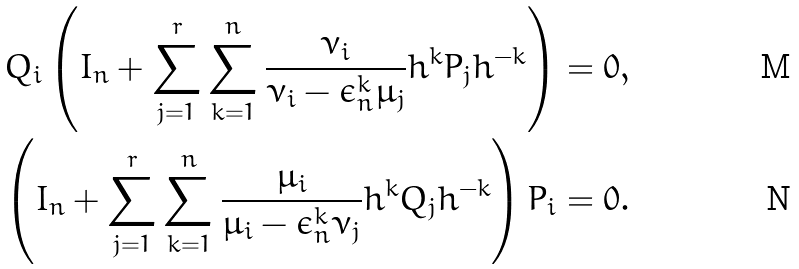<formula> <loc_0><loc_0><loc_500><loc_500>Q _ { i } \left ( I _ { n } + \sum _ { j = 1 } ^ { r } \sum _ { k = 1 } ^ { n } \frac { \nu _ { i } } { \nu _ { i } - \epsilon _ { n } ^ { k } \mu _ { j } } h ^ { k } P _ { j } h ^ { - k } \right ) = 0 , \\ \left ( I _ { n } + \sum _ { j = 1 } ^ { r } \sum _ { k = 1 } ^ { n } \frac { \mu _ { i } } { \mu _ { i } - \epsilon _ { n } ^ { k } \nu _ { j } } h ^ { k } Q _ { j } h ^ { - k } \right ) P _ { i } = 0 .</formula> 